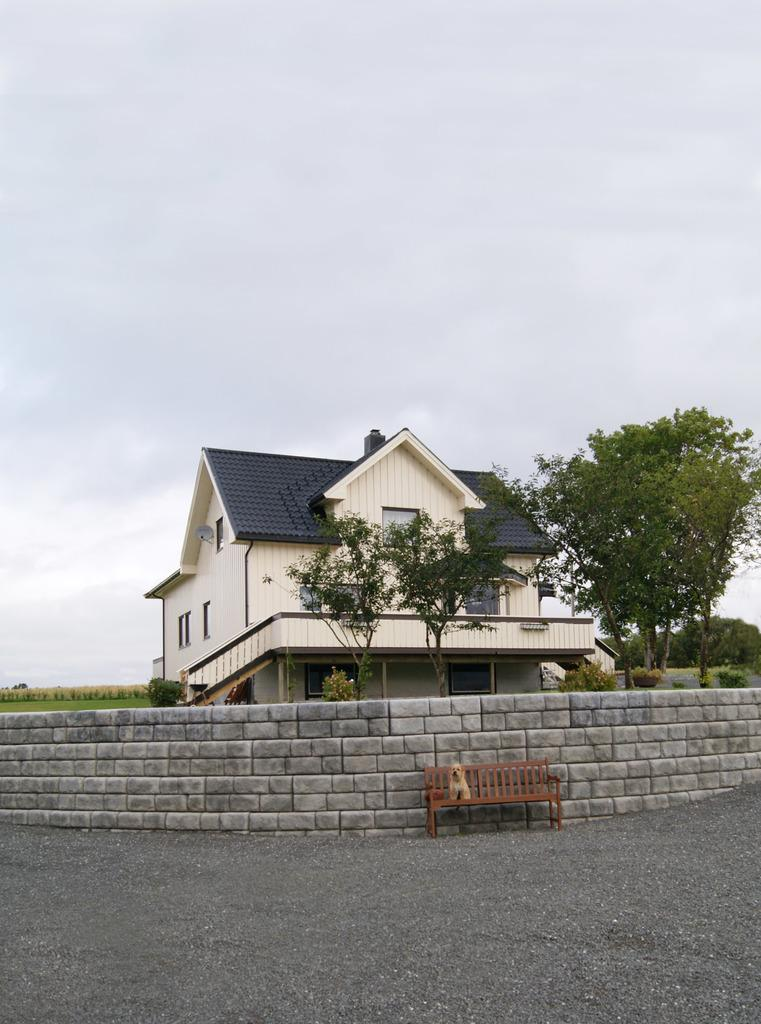What is on the ground in the image? There is a bench on the ground in the image. What is sitting on the bench? A dog is on the bench. What can be seen behind the bench? There is a wall in the image. What type of structure is visible in the image? There is a building in the image. What type of vegetation is present in the image? Trees are present in the image. What is visible in the background of the image? The sky is visible in the background of the image. What type of chain is the dog wearing in the image? There is no chain visible on the dog in the image. How does the wall in the image get the attention of the dog? The wall in the image does not actively get the attention of the dog; the dog is simply sitting on the bench. 